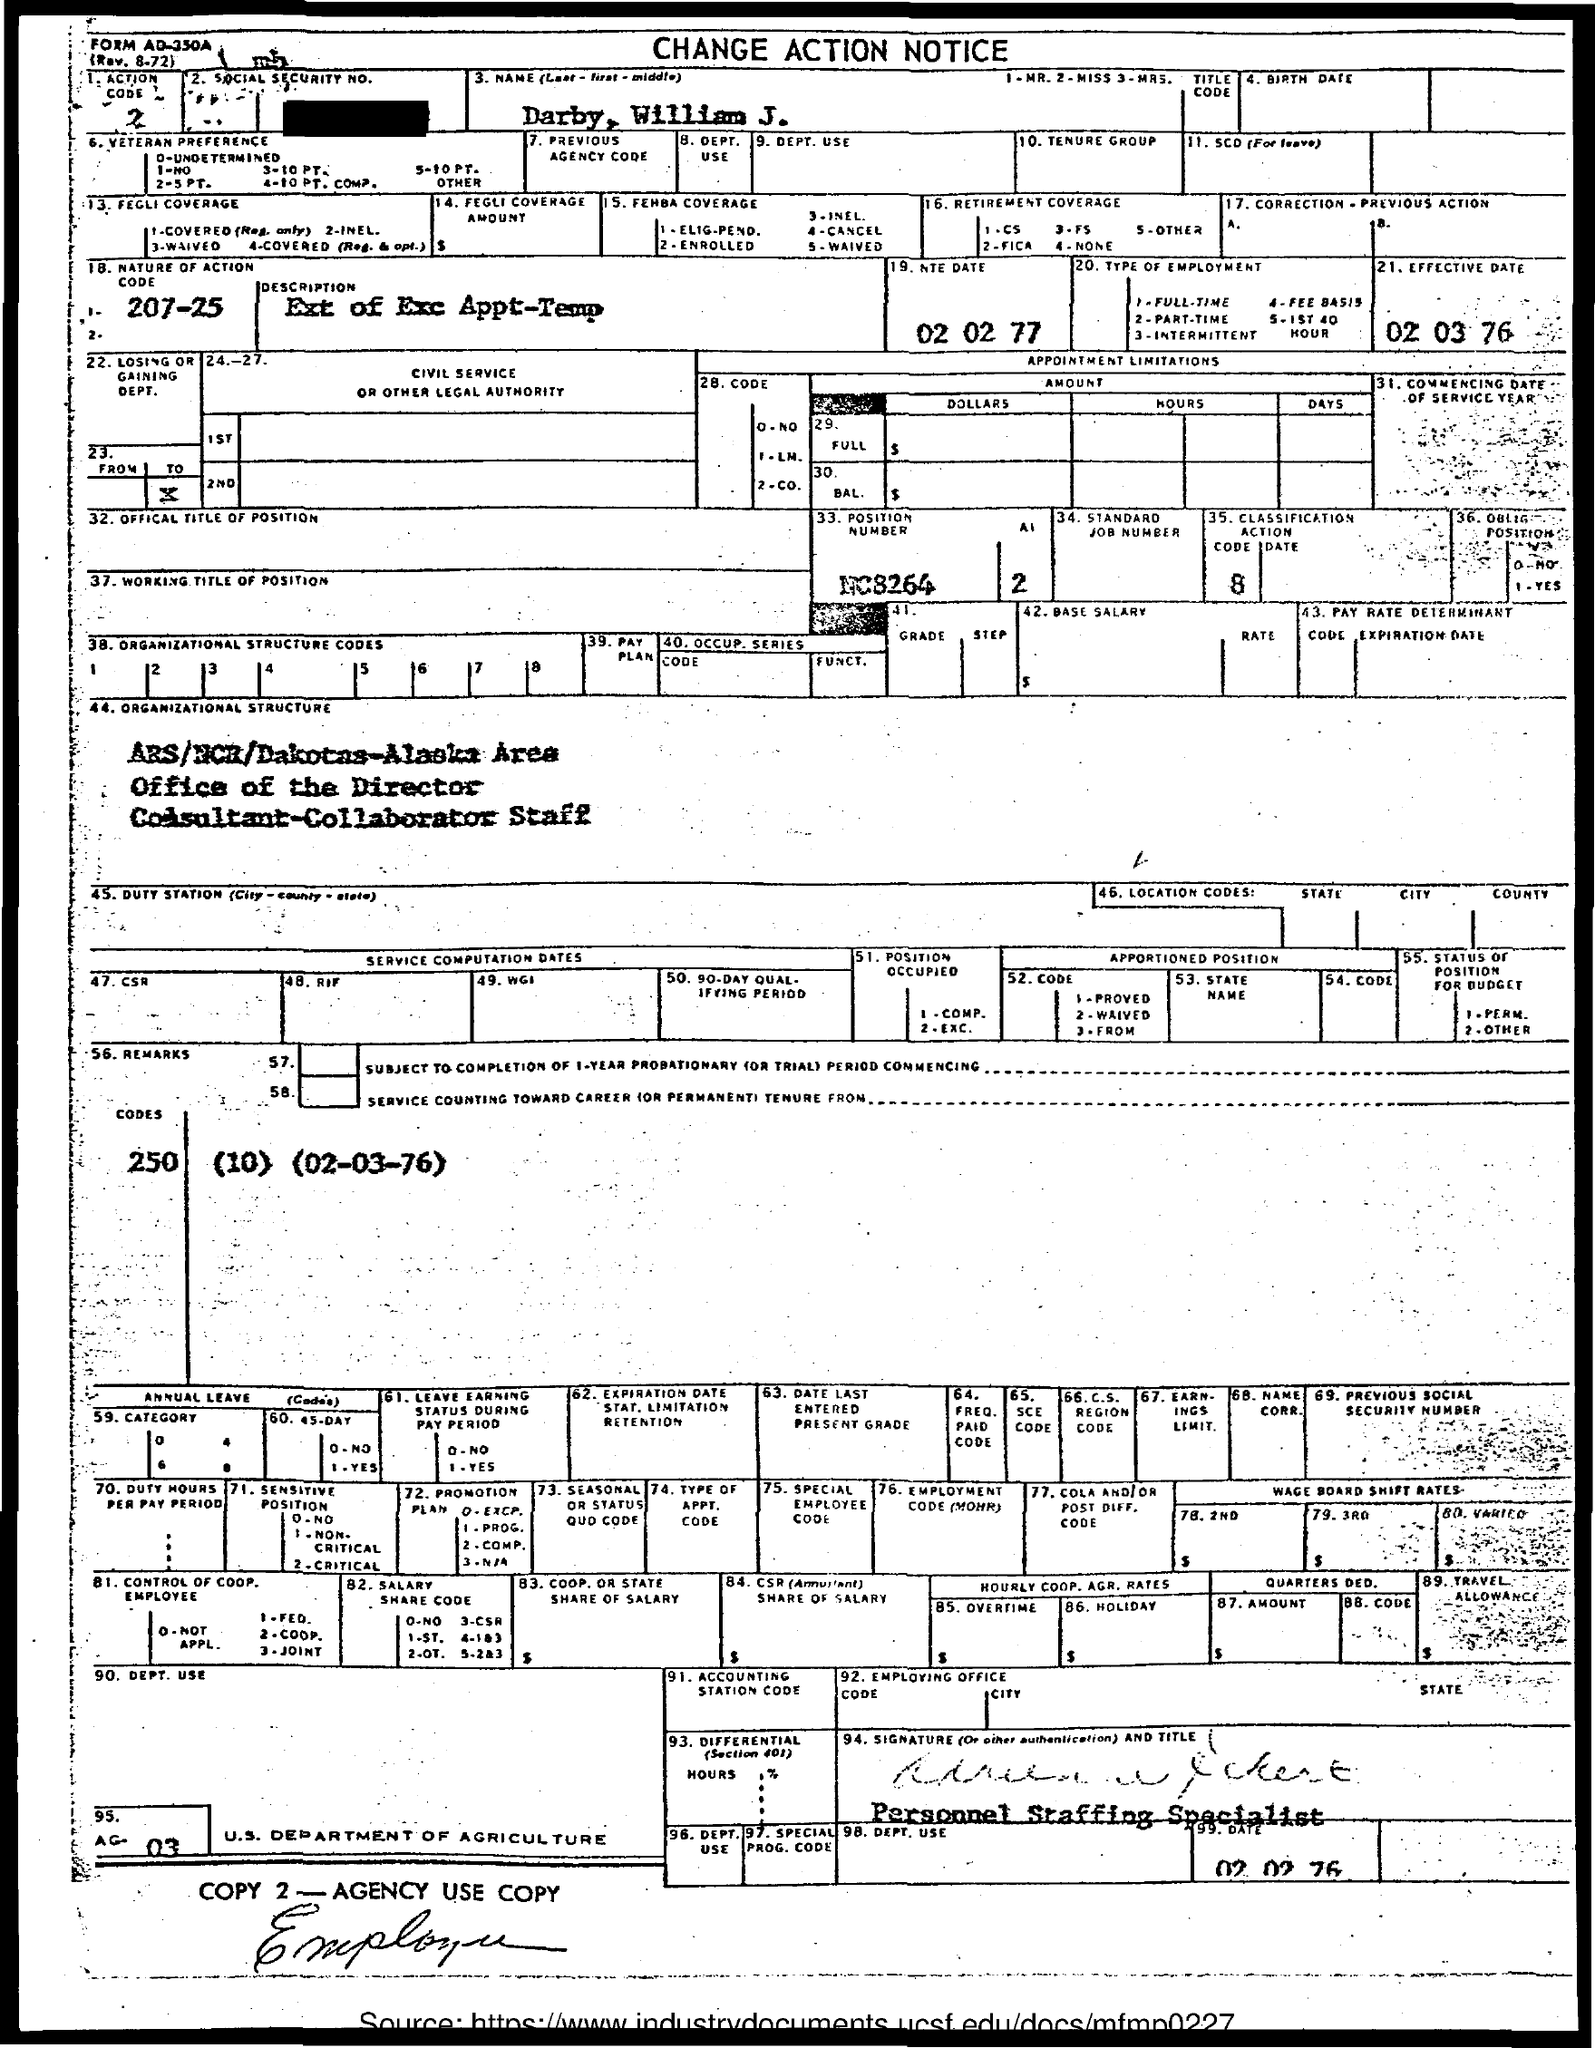Outline some significant characteristics in this image. What is the effective date? It is March 2, 1976. The nature of action code is unknown, specifically between the range of 207 to 25 